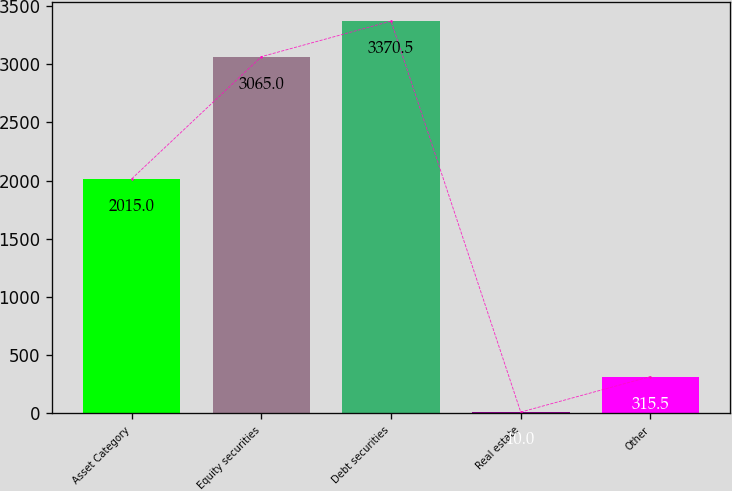<chart> <loc_0><loc_0><loc_500><loc_500><bar_chart><fcel>Asset Category<fcel>Equity securities<fcel>Debt securities<fcel>Real estate<fcel>Other<nl><fcel>2015<fcel>3065<fcel>3370.5<fcel>10<fcel>315.5<nl></chart> 